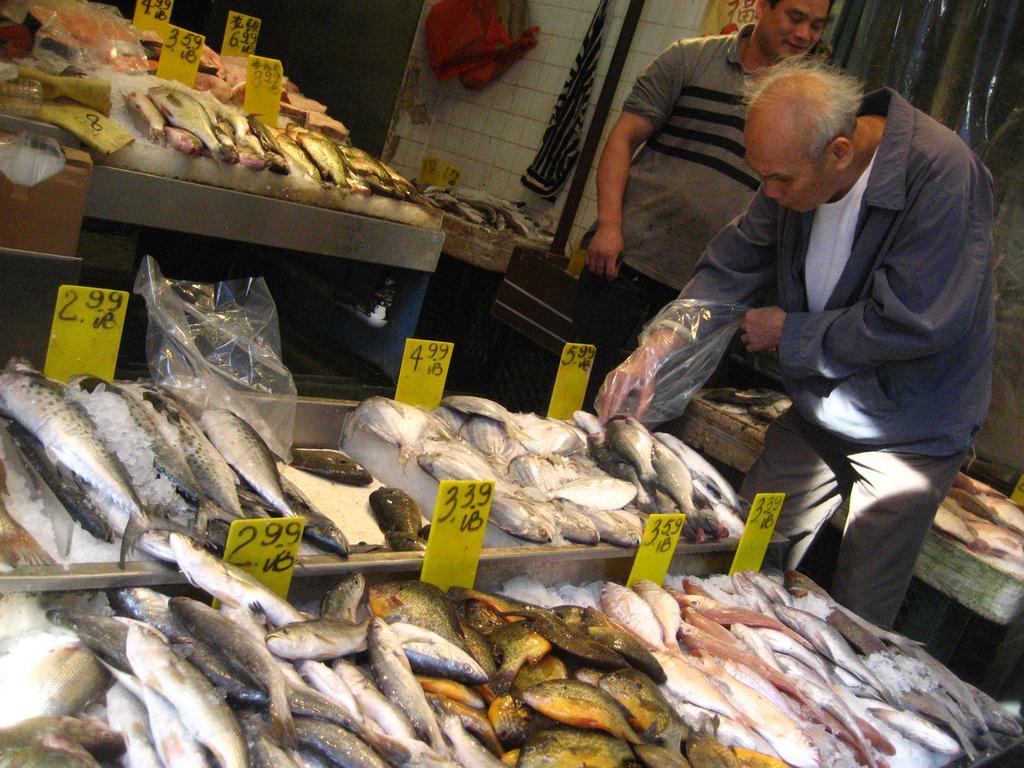Could you give a brief overview of what you see in this image? In this image in the foreground there are fishes kept on table , on which there are few price tags attached to the table, on the right side two persons visible one person wearing plastic cover touching the fish, at the top there is table on which there are fishes and price tags visible, on the right side there is the wall, and cloth hanging on the wall, there is a pole, beside the pole fishes kept on table. 